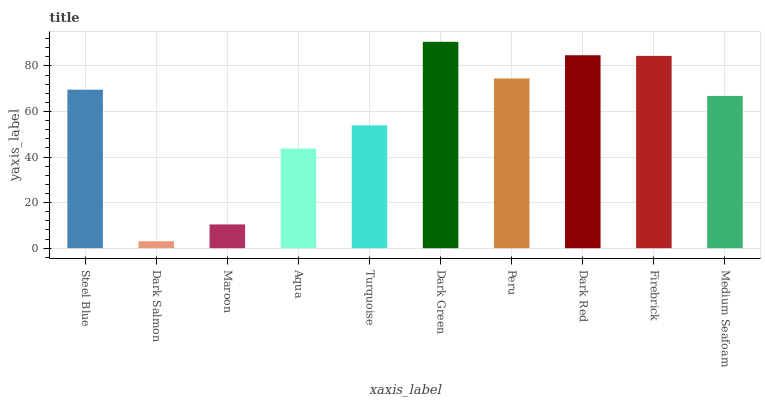Is Dark Salmon the minimum?
Answer yes or no. Yes. Is Dark Green the maximum?
Answer yes or no. Yes. Is Maroon the minimum?
Answer yes or no. No. Is Maroon the maximum?
Answer yes or no. No. Is Maroon greater than Dark Salmon?
Answer yes or no. Yes. Is Dark Salmon less than Maroon?
Answer yes or no. Yes. Is Dark Salmon greater than Maroon?
Answer yes or no. No. Is Maroon less than Dark Salmon?
Answer yes or no. No. Is Steel Blue the high median?
Answer yes or no. Yes. Is Medium Seafoam the low median?
Answer yes or no. Yes. Is Maroon the high median?
Answer yes or no. No. Is Dark Salmon the low median?
Answer yes or no. No. 